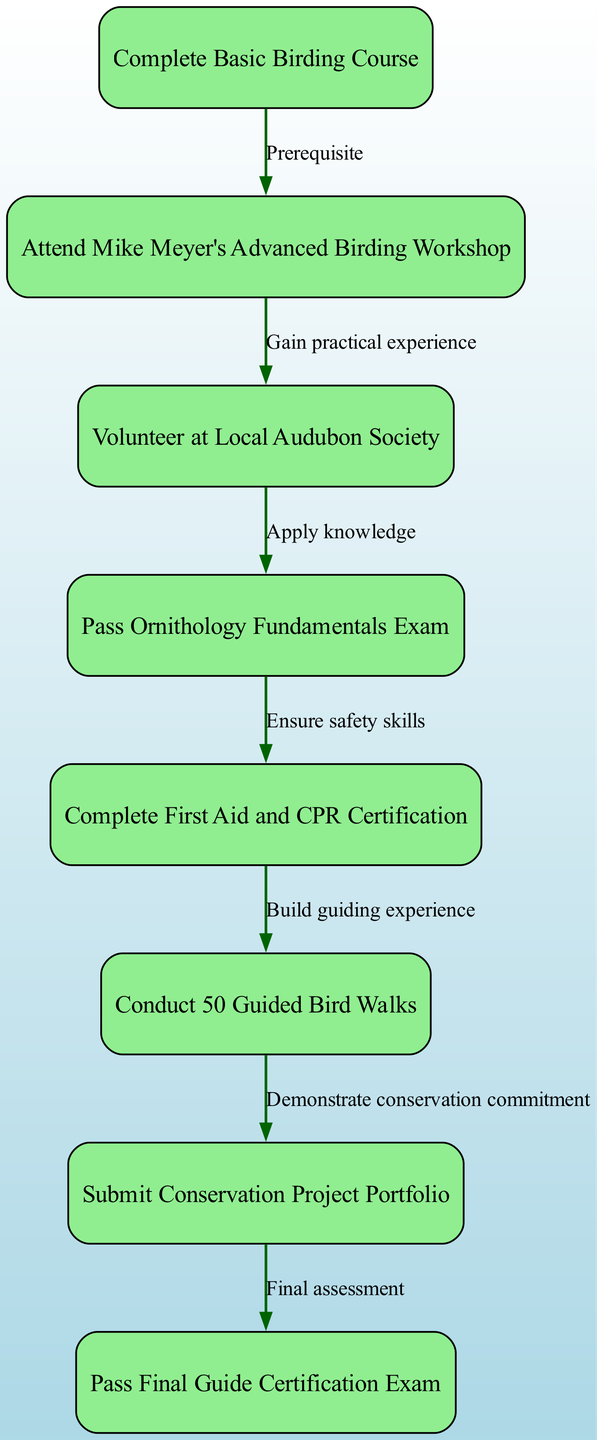What is the first step in the certification process? The first step is to "Complete Basic Birding Course," which is the starting point in the pathway.
Answer: Complete Basic Birding Course How many nodes are in the diagram? The diagram includes eight nodes representing each step in the certification process, from beginning to the final certification exam.
Answer: Eight What is required after conducting 50 guided bird walks? After conducting 50 guided bird walks, the next requirement is to "Submit Conservation Project Portfolio," demonstrating further commitment to conservation.
Answer: Submit Conservation Project Portfolio Which course is a prerequisite for attending Mike Meyer's Advanced Birding Workshop? The prerequisite course is "Complete Basic Birding Course," which must be finished before advancing to the workshop.
Answer: Complete Basic Birding Course What is the final step before achieving certification? The final step before achieving certification is to "Pass Final Guide Certification Exam," which assesses all the accumulated knowledge and skills.
Answer: Pass Final Guide Certification Exam In what step do participants apply their knowledge? Participants apply their knowledge in the step where they "Volunteer at Local Audubon Society," gaining practical experience in the field.
Answer: Volunteer at Local Audubon Society What connects passing the Ornithology Fundamentals Exam to ensuring safety skills? The connection is through the edge labeled "Ensure safety skills," which shows that passing the exam leads to completing First Aid and CPR Certification to ensure safety during guiding.
Answer: Ensure safety skills What action demonstrates conservation commitment in the pathway? Conducting 50 Guided Bird Walks demonstrates conservation commitment, as indicated by the flow from conducting walks to submitting a conservation project portfolio.
Answer: Conduct 50 Guided Bird Walks 